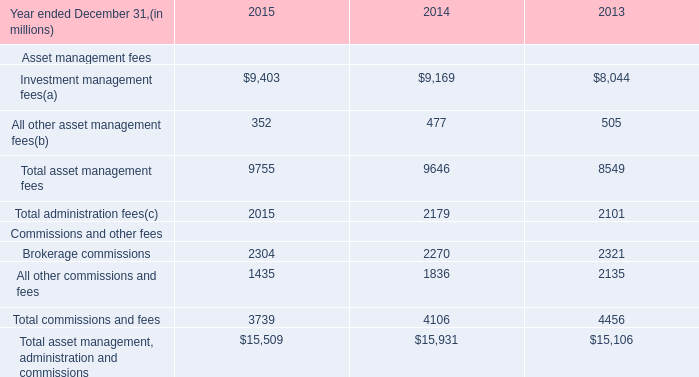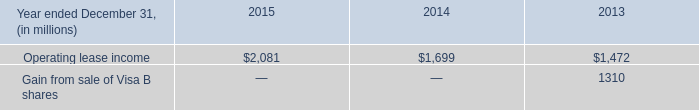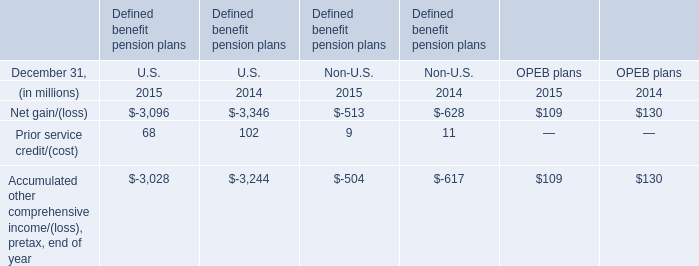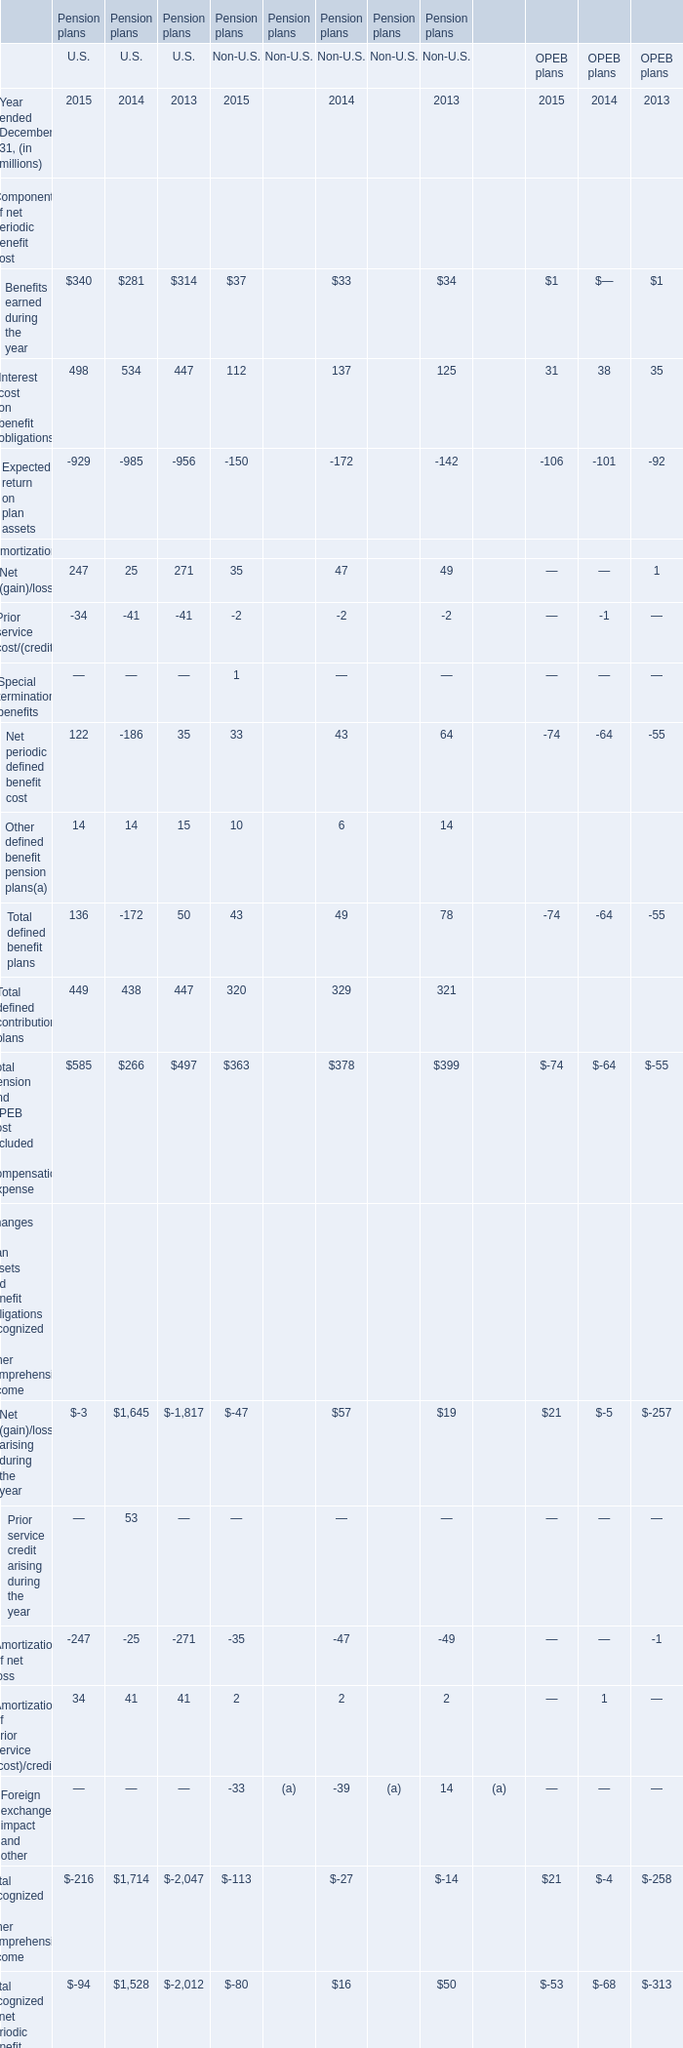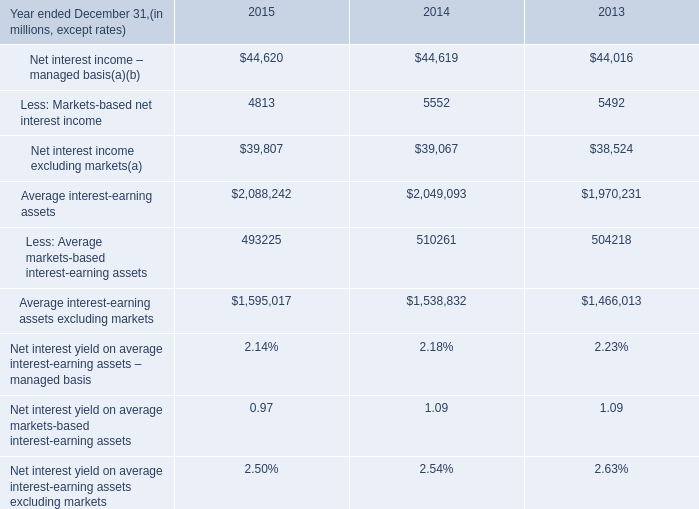what is the highest total amount of Net periodic defined benefit cost? (in million) 
Answer: 122. 